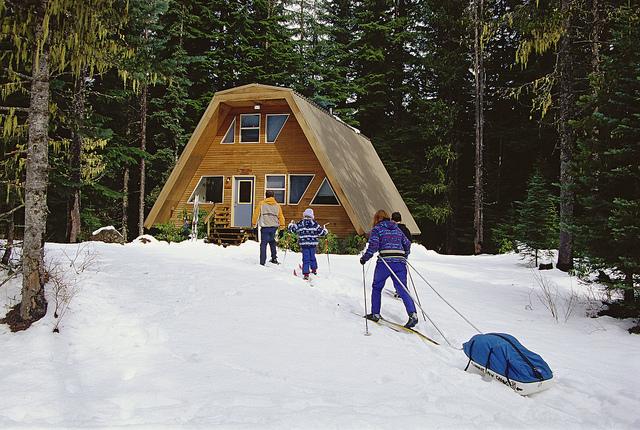How easy is it to drive in these conditions?
Answer briefly. Difficult. What are the people carrying?
Keep it brief. Ski poles. How many cars are in this photo?
Answer briefly. 0. What style of home is this?
Quick response, please. Cabin. Is this location cold?
Be succinct. Yes. What color are the pants of the person closest to the camera?
Keep it brief. Blue. Is this skier posing?
Quick response, please. No. 